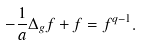<formula> <loc_0><loc_0><loc_500><loc_500>- \frac { 1 } { a } \Delta _ { g } f + f = f ^ { q - 1 } .</formula> 